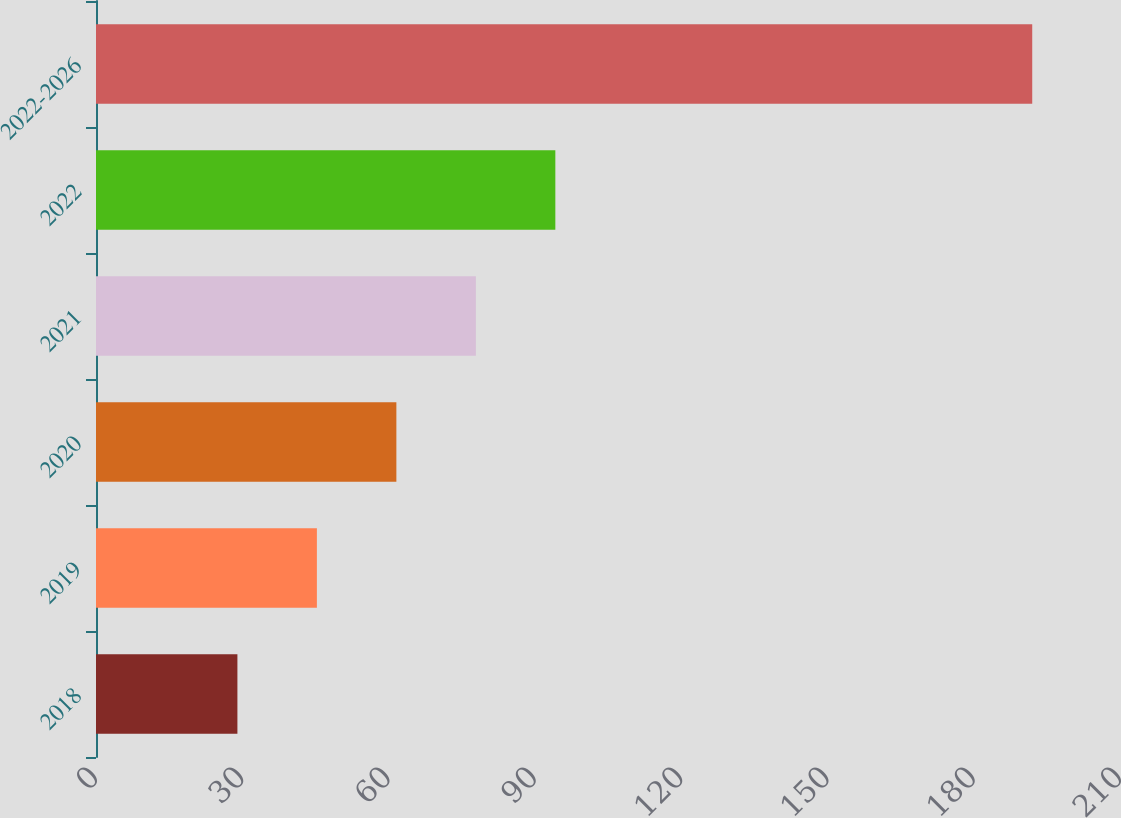<chart> <loc_0><loc_0><loc_500><loc_500><bar_chart><fcel>2018<fcel>2019<fcel>2020<fcel>2021<fcel>2022<fcel>2022-2026<nl><fcel>29<fcel>45.3<fcel>61.6<fcel>77.9<fcel>94.2<fcel>192<nl></chart> 